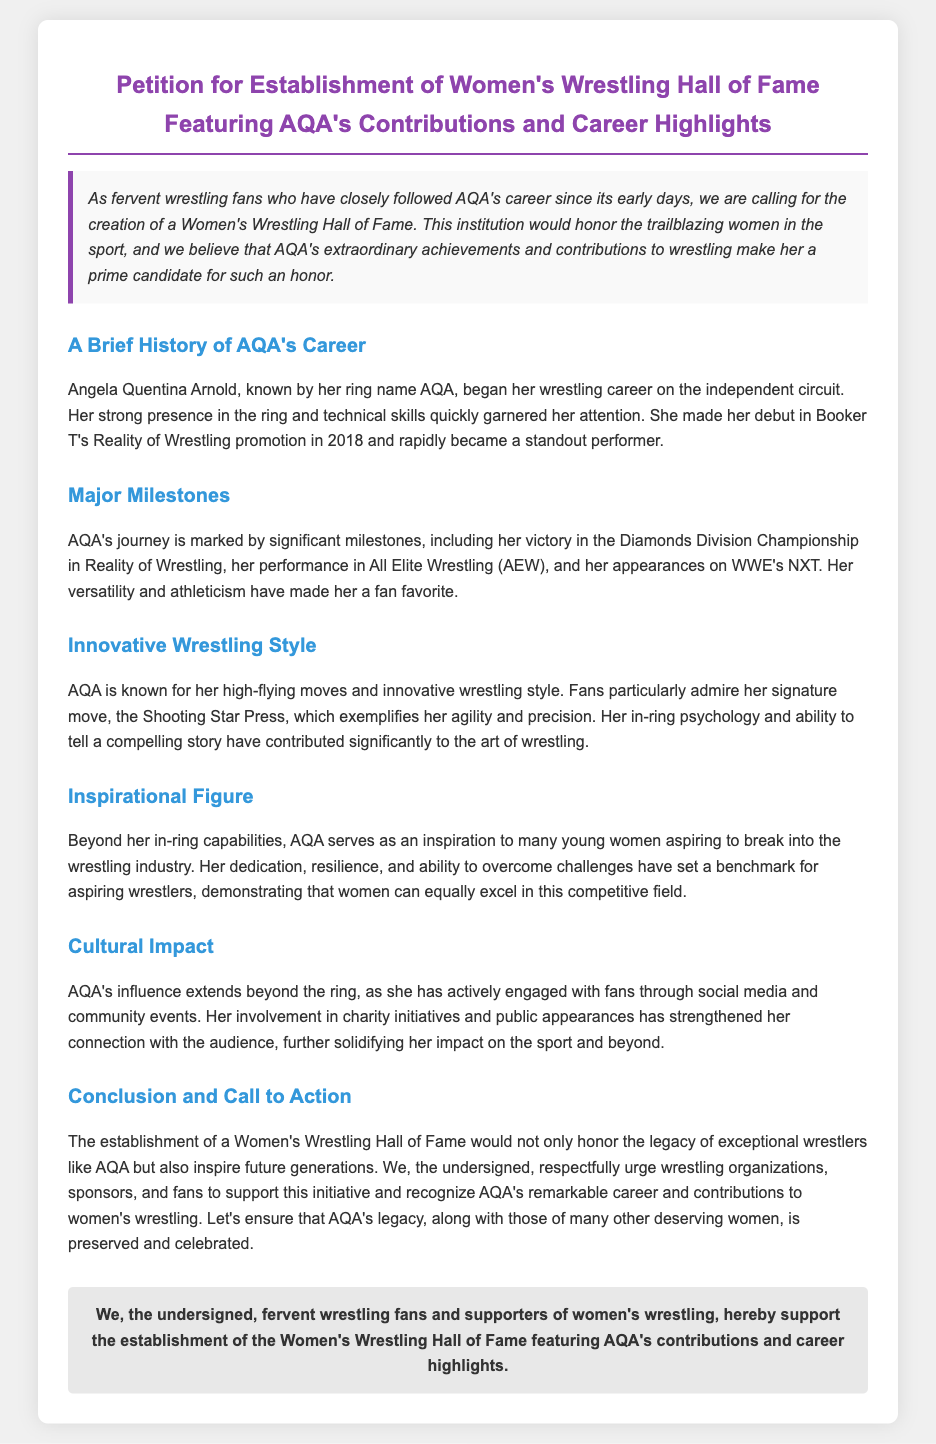what is AQA's full name? AQA's full name is provided in the document as Angela Quentina Arnold.
Answer: Angela Quentina Arnold when did AQA make her debut? The document states that AQA made her debut in 2018.
Answer: 2018 what championship did AQA win in Reality of Wrestling? The document mentions that AQA won the Diamonds Division Championship.
Answer: Diamonds Division Championship what is AQA's signature move? According to the document, AQA's signature move is the Shooting Star Press.
Answer: Shooting Star Press how does AQA inspire young women? The document indicates that AQA serves as an inspiration through her dedication, resilience, and overcoming challenges.
Answer: dedication, resilience, and overcoming challenges what type of impact does AQA have beyond wrestling? The document notes that AQA's influence extends to community engagement and charity initiatives.
Answer: community engagement and charity initiatives what is the primary call to action in the petition? The petition calls for support in establishing a Women's Wrestling Hall of Fame honoring AQA and other wrestlers.
Answer: support in establishing a Women's Wrestling Hall of Fame who is the intended audience for the petition? The document indicates that the intended audience includes wrestling organizations, sponsors, and fans.
Answer: wrestling organizations, sponsors, and fans 